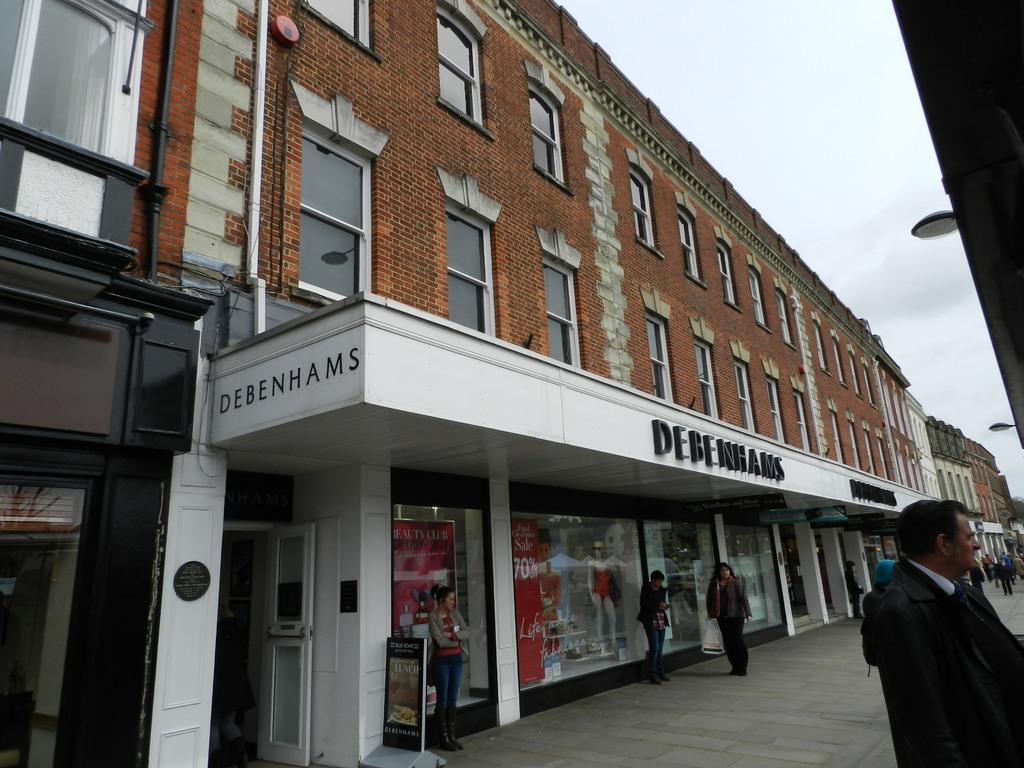Can you describe this image briefly? In this picture we can see a few people on the path. There are lights on the right side. We can see a few posts and mannequin in a building on the left side. We can see some buildings in the background. 